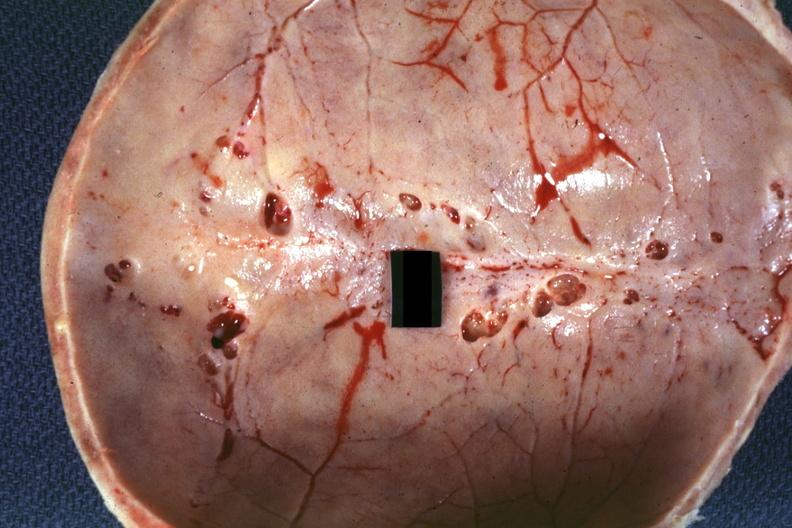does this image show inner table view multiple venous lakes?
Answer the question using a single word or phrase. Yes 